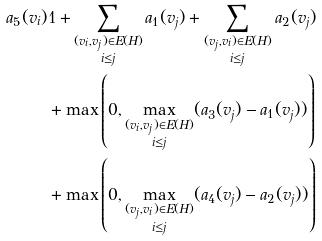Convert formula to latex. <formula><loc_0><loc_0><loc_500><loc_500>a _ { 5 } ( v _ { i } ) & 1 + \sum _ { \substack { ( v _ { i } , v _ { j } ) \in E ( H ) \\ i \leq j } } a _ { 1 } ( v _ { j } ) + \sum _ { \substack { ( v _ { j } , v _ { i } ) \in E ( H ) \\ i \leq j } } a _ { 2 } ( v _ { j } ) \\ & + \max \left ( 0 , \max _ { \substack { ( v _ { i } , v _ { j } ) \in E ( H ) \\ i \leq j } } ( a _ { 3 } ( v _ { j } ) - a _ { 1 } ( v _ { j } ) ) \right ) \\ & + \max \left ( 0 , \max _ { \substack { ( v _ { j } , v _ { i } ) \in E ( H ) \\ i \leq j } } ( a _ { 4 } ( v _ { j } ) - a _ { 2 } ( v _ { j } ) ) \right )</formula> 